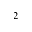<formula> <loc_0><loc_0><loc_500><loc_500>_ { 2 }</formula> 